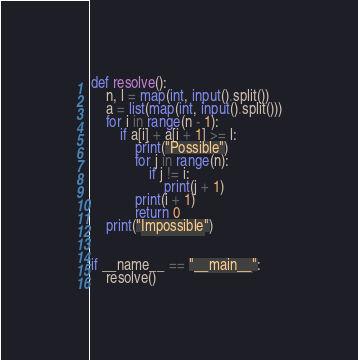<code> <loc_0><loc_0><loc_500><loc_500><_Python_>def resolve():
    n, l = map(int, input().split())
    a = list(map(int, input().split()))
    for i in range(n - 1):
        if a[i] + a[i + 1] >= l:
            print("Possible")
            for j in range(n):
                if j != i:
                    print(j + 1)
            print(i + 1)
            return 0
    print("Impossible")


if __name__ == "__main__":
    resolve()
</code> 